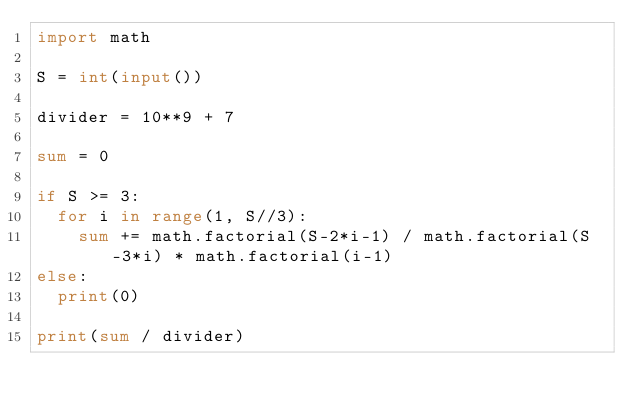Convert code to text. <code><loc_0><loc_0><loc_500><loc_500><_Python_>import math

S = int(input())

divider = 10**9 + 7

sum = 0

if S >= 3:
  for i in range(1, S//3):
    sum += math.factorial(S-2*i-1) / math.factorial(S-3*i) * math.factorial(i-1)
else:
  print(0)
  
print(sum / divider)</code> 